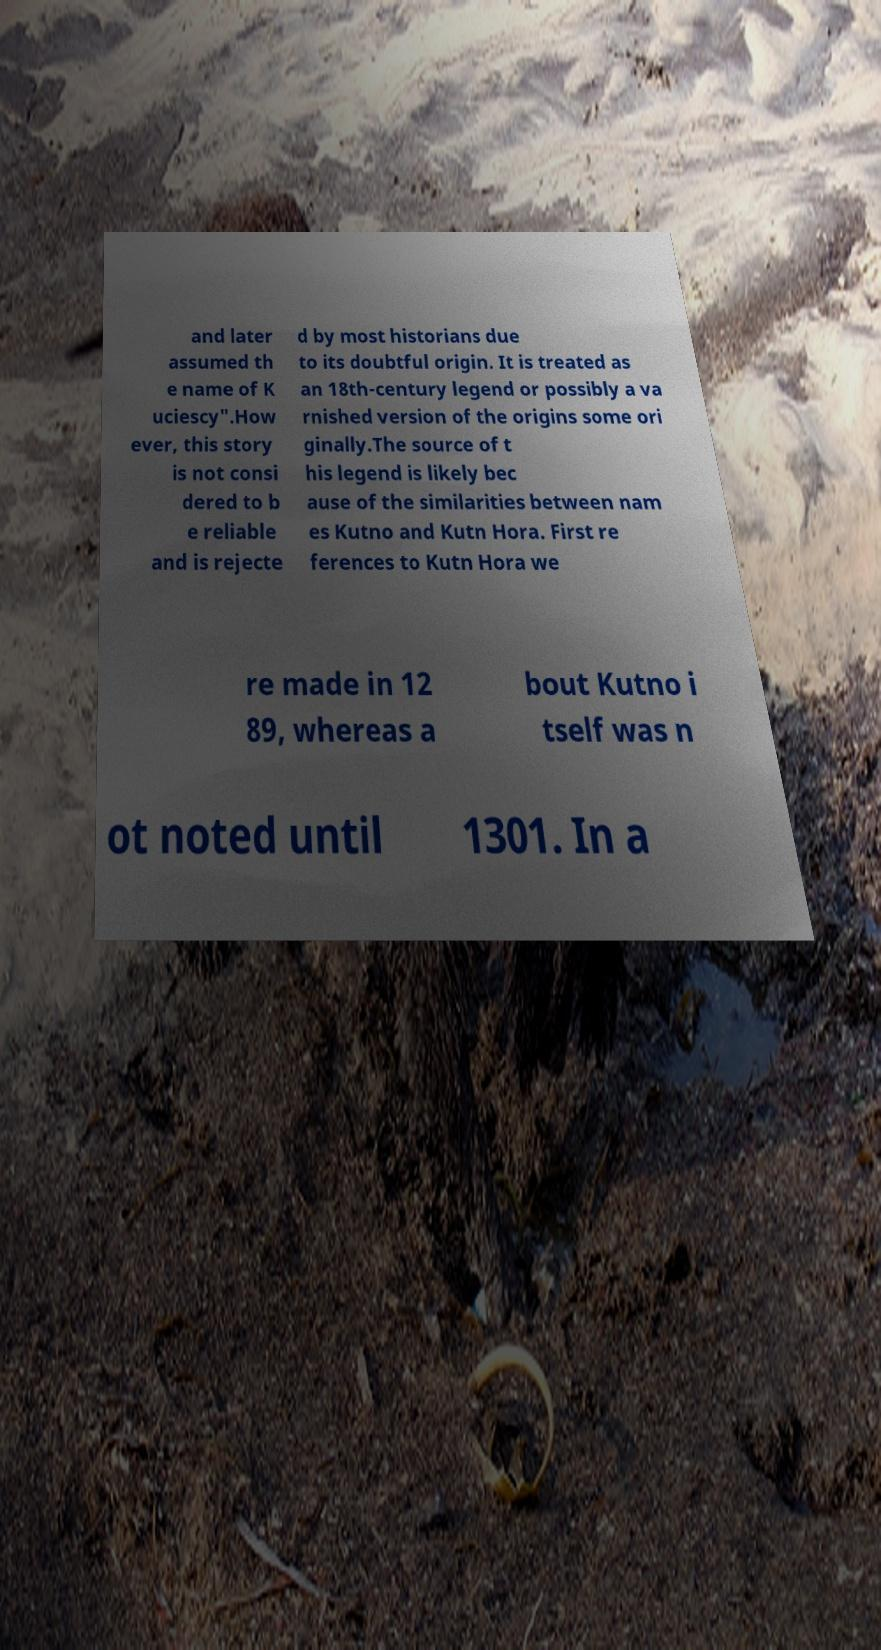Could you extract and type out the text from this image? and later assumed th e name of K uciescy".How ever, this story is not consi dered to b e reliable and is rejecte d by most historians due to its doubtful origin. It is treated as an 18th-century legend or possibly a va rnished version of the origins some ori ginally.The source of t his legend is likely bec ause of the similarities between nam es Kutno and Kutn Hora. First re ferences to Kutn Hora we re made in 12 89, whereas a bout Kutno i tself was n ot noted until 1301. In a 